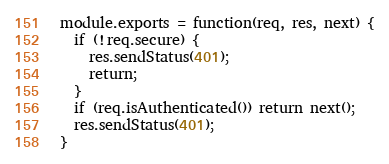Convert code to text. <code><loc_0><loc_0><loc_500><loc_500><_JavaScript_>module.exports = function(req, res, next) {
  if (!req.secure) {
    res.sendStatus(401);
    return;
  }
  if (req.isAuthenticated()) return next();
  res.sendStatus(401);
}
</code> 